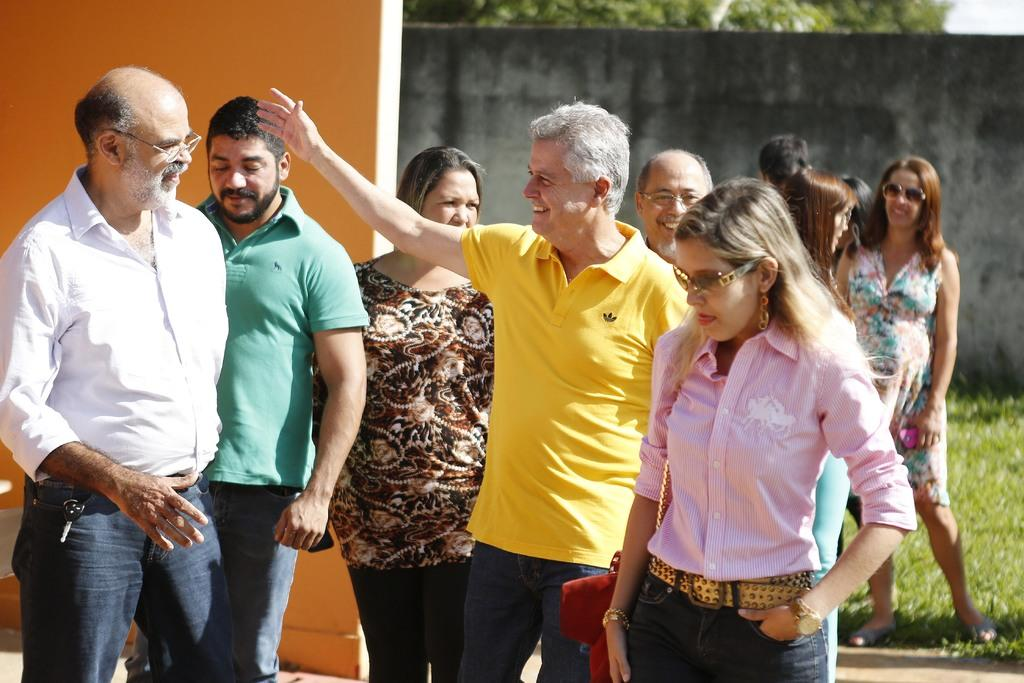What is present in the foreground of the image? There are people standing in the image. What can be seen in the background of the image? Walls, grass, trees, and the sky are visible in the background of the image. What type of bait is being used to catch the mice in the image? There is no bait or mice present in the image. How many geese are visible in the image? There are no geese visible in the image. 